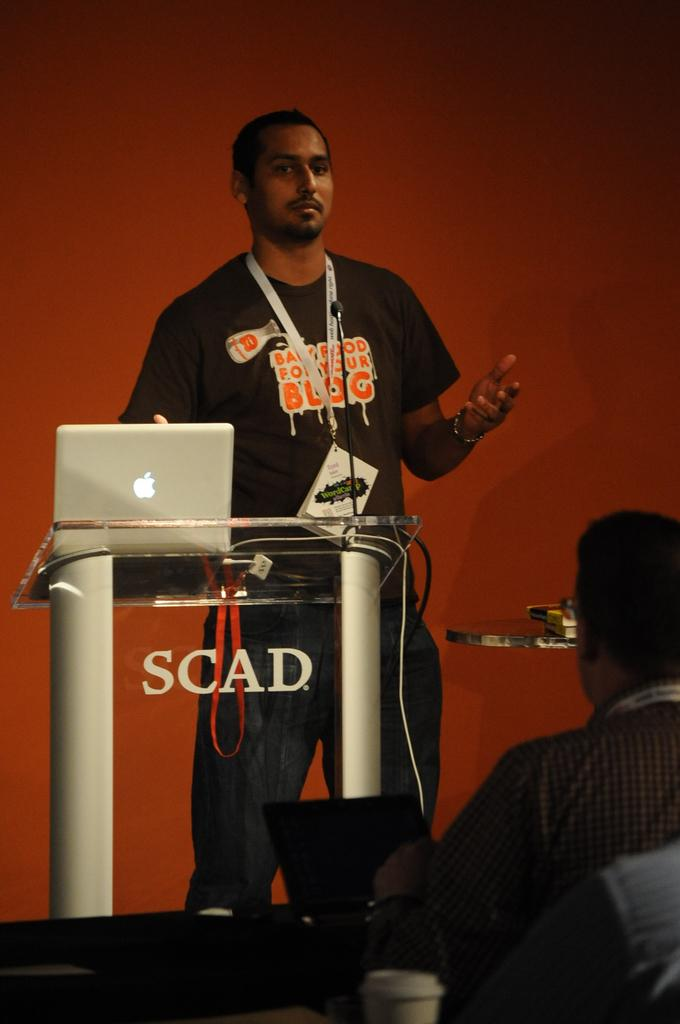What is the main subject of the image? There is a man standing in the image. Can you describe the person in front of the man? There is a person in front of the man, but their specific features are not mentioned in the facts. What object is used for amplifying sound in the image? A microphone (mic) is present in the image. What is the man standing near in the image? There is a podium in the image. What electronic devices are visible in the image? Laptops are visible in the image. What type of object is made of glass in the image? There is a glass object in the image. What type of reading material is present in the image? Books are present in the image. Can you describe any unspecified objects in the image? There are some unspecified objects in the image, but their specific features are not mentioned in the facts. What can be seen in the background of the image? There is a wall in the background of the image. What type of smile can be seen on the man's face in the image? The facts do not mention any facial expressions, so we cannot determine if the man is smiling or not. What type of pain is the man experiencing in the image? The facts do not mention any pain or discomfort, so we cannot determine if the man is in pain or not. 